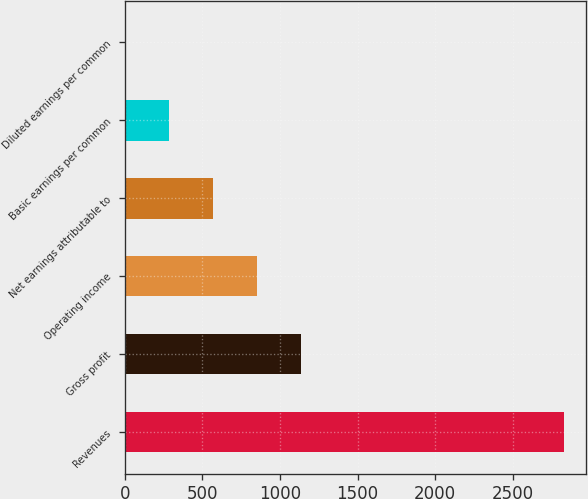<chart> <loc_0><loc_0><loc_500><loc_500><bar_chart><fcel>Revenues<fcel>Gross profit<fcel>Operating income<fcel>Net earnings attributable to<fcel>Basic earnings per common<fcel>Diluted earnings per common<nl><fcel>2831.3<fcel>1134.38<fcel>851.56<fcel>568.74<fcel>285.92<fcel>3.1<nl></chart> 